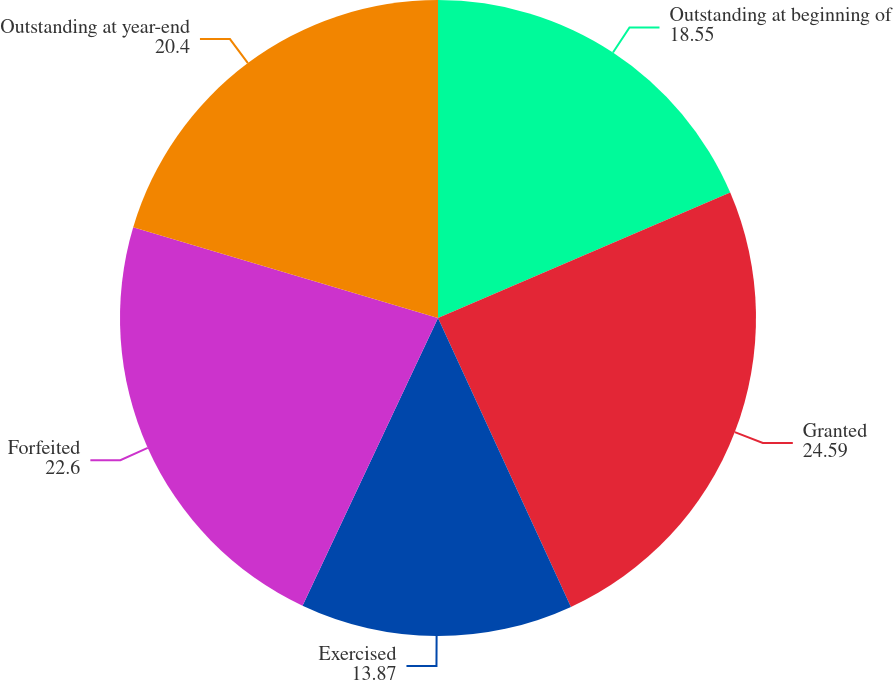<chart> <loc_0><loc_0><loc_500><loc_500><pie_chart><fcel>Outstanding at beginning of<fcel>Granted<fcel>Exercised<fcel>Forfeited<fcel>Outstanding at year-end<nl><fcel>18.55%<fcel>24.59%<fcel>13.87%<fcel>22.6%<fcel>20.4%<nl></chart> 